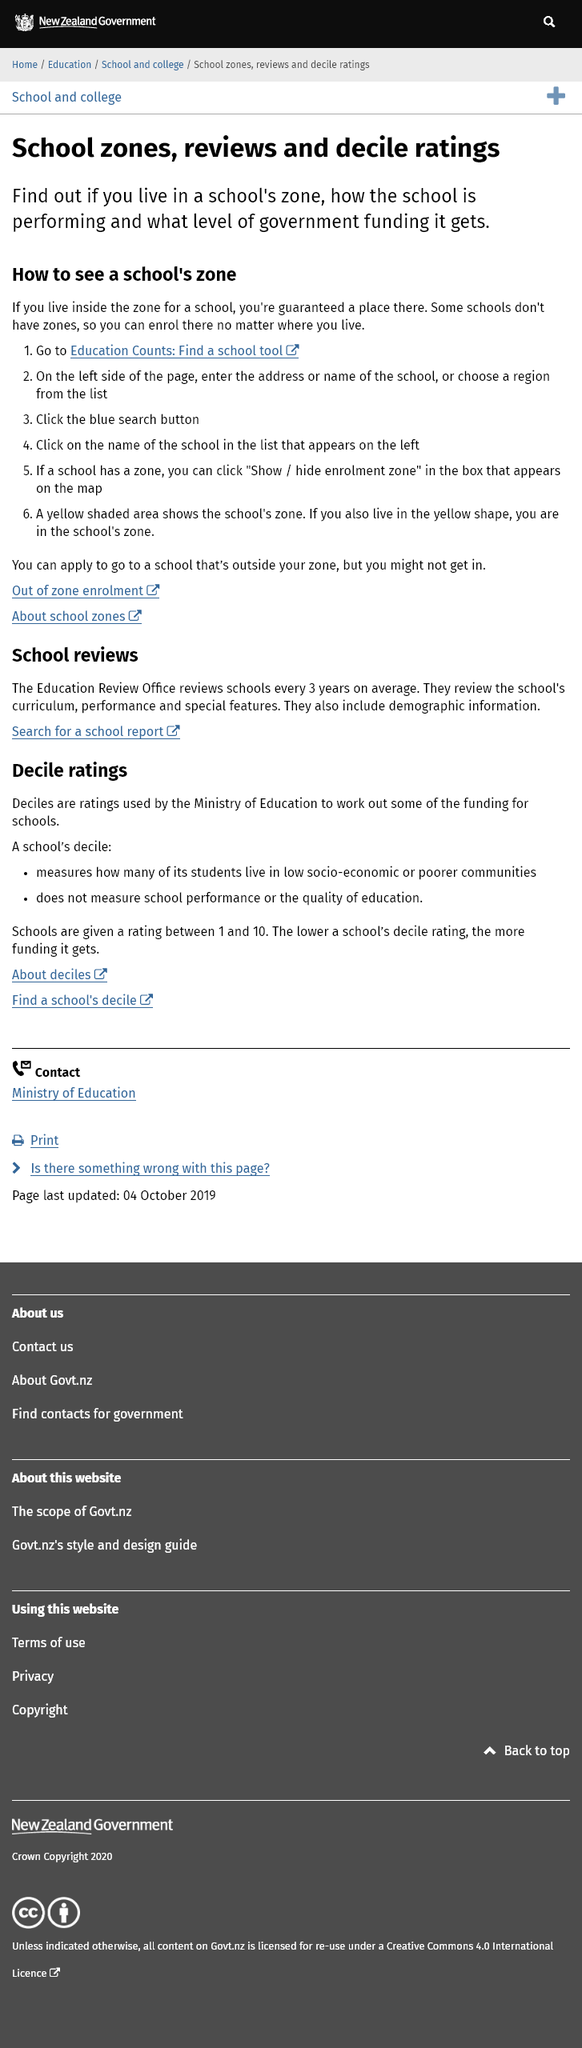Outline some significant characteristics in this image. Yes, it is possible for individuals who do not reside in the yellow shaded area to apply to the school, but they may have a lower chance of being accepted. The first step to seeing a school's zone is to visit the Education Counts: Find a school tool website. Some schools have zones, but not all schools have zones. Additionally, some schools do not have zones. 